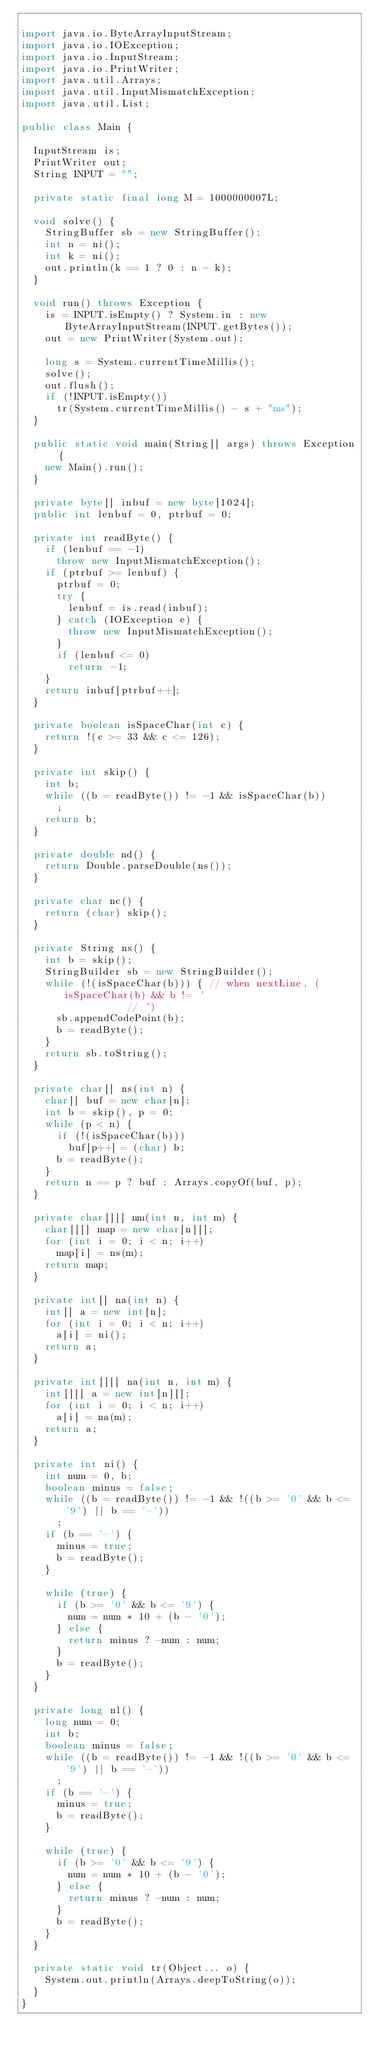<code> <loc_0><loc_0><loc_500><loc_500><_Java_>
import java.io.ByteArrayInputStream;
import java.io.IOException;
import java.io.InputStream;
import java.io.PrintWriter;
import java.util.Arrays;
import java.util.InputMismatchException;
import java.util.List;

public class Main {

	InputStream is;
	PrintWriter out;
	String INPUT = "";

	private static final long M = 1000000007L;

	void solve() {
		StringBuffer sb = new StringBuffer();
		int n = ni();
		int k = ni();
		out.println(k == 1 ? 0 : n - k);
	}

	void run() throws Exception {
		is = INPUT.isEmpty() ? System.in : new ByteArrayInputStream(INPUT.getBytes());
		out = new PrintWriter(System.out);

		long s = System.currentTimeMillis();
		solve();
		out.flush();
		if (!INPUT.isEmpty())
			tr(System.currentTimeMillis() - s + "ms");
	}

	public static void main(String[] args) throws Exception {
		new Main().run();
	}

	private byte[] inbuf = new byte[1024];
	public int lenbuf = 0, ptrbuf = 0;

	private int readByte() {
		if (lenbuf == -1)
			throw new InputMismatchException();
		if (ptrbuf >= lenbuf) {
			ptrbuf = 0;
			try {
				lenbuf = is.read(inbuf);
			} catch (IOException e) {
				throw new InputMismatchException();
			}
			if (lenbuf <= 0)
				return -1;
		}
		return inbuf[ptrbuf++];
	}

	private boolean isSpaceChar(int c) {
		return !(c >= 33 && c <= 126);
	}

	private int skip() {
		int b;
		while ((b = readByte()) != -1 && isSpaceChar(b))
			;
		return b;
	}

	private double nd() {
		return Double.parseDouble(ns());
	}

	private char nc() {
		return (char) skip();
	}

	private String ns() {
		int b = skip();
		StringBuilder sb = new StringBuilder();
		while (!(isSpaceChar(b))) { // when nextLine, (isSpaceChar(b) && b != '
									// ')
			sb.appendCodePoint(b);
			b = readByte();
		}
		return sb.toString();
	}

	private char[] ns(int n) {
		char[] buf = new char[n];
		int b = skip(), p = 0;
		while (p < n) {
			if (!(isSpaceChar(b)))
				buf[p++] = (char) b;
			b = readByte();
		}
		return n == p ? buf : Arrays.copyOf(buf, p);
	}

	private char[][] nm(int n, int m) {
		char[][] map = new char[n][];
		for (int i = 0; i < n; i++)
			map[i] = ns(m);
		return map;
	}

	private int[] na(int n) {
		int[] a = new int[n];
		for (int i = 0; i < n; i++)
			a[i] = ni();
		return a;
	}

	private int[][] na(int n, int m) {
		int[][] a = new int[n][];
		for (int i = 0; i < n; i++)
			a[i] = na(m);
		return a;
	}

	private int ni() {
		int num = 0, b;
		boolean minus = false;
		while ((b = readByte()) != -1 && !((b >= '0' && b <= '9') || b == '-'))
			;
		if (b == '-') {
			minus = true;
			b = readByte();
		}

		while (true) {
			if (b >= '0' && b <= '9') {
				num = num * 10 + (b - '0');
			} else {
				return minus ? -num : num;
			}
			b = readByte();
		}
	}

	private long nl() {
		long num = 0;
		int b;
		boolean minus = false;
		while ((b = readByte()) != -1 && !((b >= '0' && b <= '9') || b == '-'))
			;
		if (b == '-') {
			minus = true;
			b = readByte();
		}

		while (true) {
			if (b >= '0' && b <= '9') {
				num = num * 10 + (b - '0');
			} else {
				return minus ? -num : num;
			}
			b = readByte();
		}
	}

	private static void tr(Object... o) {
		System.out.println(Arrays.deepToString(o));
	}
}
</code> 